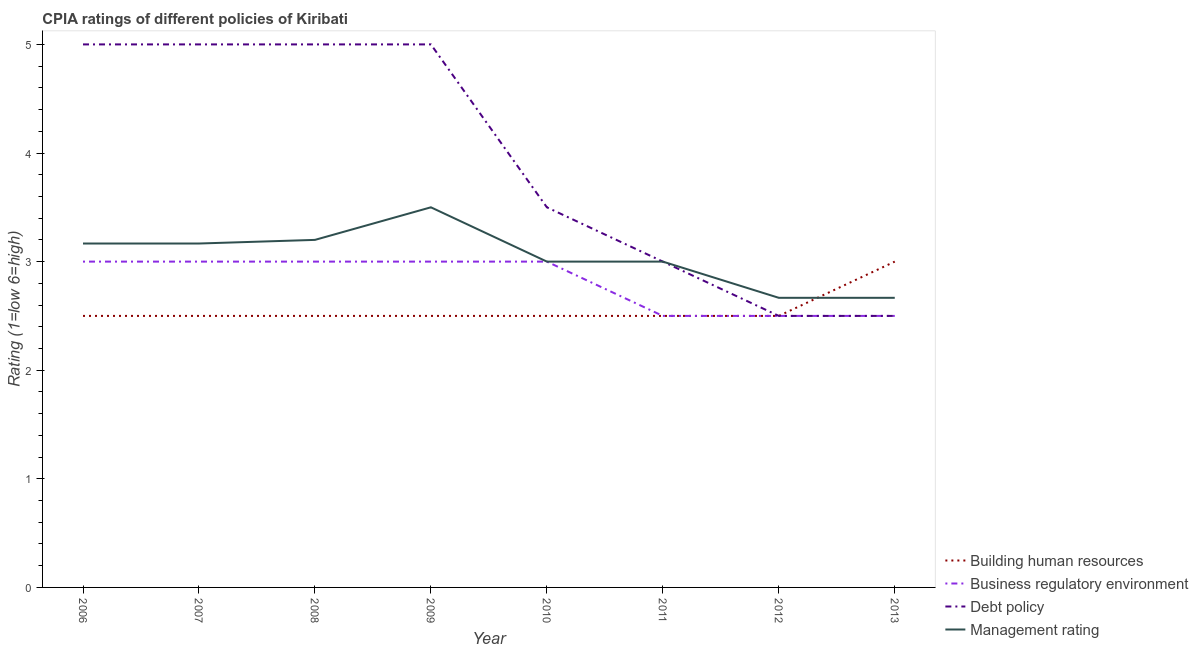How many different coloured lines are there?
Offer a terse response. 4. Is the number of lines equal to the number of legend labels?
Ensure brevity in your answer.  Yes. What is the cpia rating of debt policy in 2007?
Your answer should be very brief. 5. Across all years, what is the maximum cpia rating of business regulatory environment?
Your answer should be very brief. 3. Across all years, what is the minimum cpia rating of debt policy?
Keep it short and to the point. 2.5. In which year was the cpia rating of management maximum?
Keep it short and to the point. 2009. In which year was the cpia rating of business regulatory environment minimum?
Your answer should be very brief. 2011. What is the difference between the cpia rating of management in 2012 and the cpia rating of debt policy in 2007?
Make the answer very short. -2.33. What is the average cpia rating of management per year?
Offer a very short reply. 3.05. In the year 2012, what is the difference between the cpia rating of debt policy and cpia rating of management?
Offer a very short reply. -0.17. In how many years, is the cpia rating of management greater than 3.8?
Ensure brevity in your answer.  0. What is the ratio of the cpia rating of business regulatory environment in 2006 to that in 2013?
Your response must be concise. 1.2. Is the cpia rating of debt policy in 2006 less than that in 2007?
Offer a very short reply. No. Is the difference between the cpia rating of debt policy in 2010 and 2011 greater than the difference between the cpia rating of management in 2010 and 2011?
Keep it short and to the point. Yes. What is the difference between the highest and the second highest cpia rating of building human resources?
Your answer should be compact. 0.5. What is the difference between the highest and the lowest cpia rating of building human resources?
Keep it short and to the point. 0.5. In how many years, is the cpia rating of debt policy greater than the average cpia rating of debt policy taken over all years?
Offer a very short reply. 4. Is the sum of the cpia rating of debt policy in 2007 and 2009 greater than the maximum cpia rating of building human resources across all years?
Provide a short and direct response. Yes. Is it the case that in every year, the sum of the cpia rating of business regulatory environment and cpia rating of building human resources is greater than the sum of cpia rating of debt policy and cpia rating of management?
Your answer should be compact. No. Does the cpia rating of management monotonically increase over the years?
Your answer should be compact. No. Is the cpia rating of debt policy strictly less than the cpia rating of business regulatory environment over the years?
Your answer should be compact. No. How many lines are there?
Offer a very short reply. 4. What is the difference between two consecutive major ticks on the Y-axis?
Offer a terse response. 1. Does the graph contain any zero values?
Provide a succinct answer. No. Does the graph contain grids?
Provide a short and direct response. No. How many legend labels are there?
Your answer should be compact. 4. What is the title of the graph?
Keep it short and to the point. CPIA ratings of different policies of Kiribati. Does "Offering training" appear as one of the legend labels in the graph?
Give a very brief answer. No. What is the label or title of the X-axis?
Keep it short and to the point. Year. What is the Rating (1=low 6=high) of Building human resources in 2006?
Offer a very short reply. 2.5. What is the Rating (1=low 6=high) of Management rating in 2006?
Your response must be concise. 3.17. What is the Rating (1=low 6=high) of Building human resources in 2007?
Make the answer very short. 2.5. What is the Rating (1=low 6=high) in Debt policy in 2007?
Provide a succinct answer. 5. What is the Rating (1=low 6=high) in Management rating in 2007?
Provide a succinct answer. 3.17. What is the Rating (1=low 6=high) in Business regulatory environment in 2008?
Keep it short and to the point. 3. What is the Rating (1=low 6=high) of Management rating in 2008?
Ensure brevity in your answer.  3.2. What is the Rating (1=low 6=high) in Business regulatory environment in 2009?
Your answer should be very brief. 3. What is the Rating (1=low 6=high) of Debt policy in 2009?
Your answer should be very brief. 5. What is the Rating (1=low 6=high) of Management rating in 2009?
Provide a succinct answer. 3.5. What is the Rating (1=low 6=high) in Business regulatory environment in 2010?
Ensure brevity in your answer.  3. What is the Rating (1=low 6=high) in Building human resources in 2011?
Make the answer very short. 2.5. What is the Rating (1=low 6=high) of Debt policy in 2011?
Ensure brevity in your answer.  3. What is the Rating (1=low 6=high) in Management rating in 2012?
Ensure brevity in your answer.  2.67. What is the Rating (1=low 6=high) in Business regulatory environment in 2013?
Make the answer very short. 2.5. What is the Rating (1=low 6=high) of Management rating in 2013?
Your answer should be compact. 2.67. Across all years, what is the maximum Rating (1=low 6=high) of Building human resources?
Your answer should be compact. 3. Across all years, what is the maximum Rating (1=low 6=high) of Business regulatory environment?
Make the answer very short. 3. Across all years, what is the maximum Rating (1=low 6=high) of Management rating?
Ensure brevity in your answer.  3.5. Across all years, what is the minimum Rating (1=low 6=high) in Management rating?
Offer a very short reply. 2.67. What is the total Rating (1=low 6=high) of Building human resources in the graph?
Your answer should be very brief. 20.5. What is the total Rating (1=low 6=high) of Debt policy in the graph?
Your answer should be very brief. 31.5. What is the total Rating (1=low 6=high) of Management rating in the graph?
Offer a very short reply. 24.37. What is the difference between the Rating (1=low 6=high) of Debt policy in 2006 and that in 2007?
Give a very brief answer. 0. What is the difference between the Rating (1=low 6=high) in Building human resources in 2006 and that in 2008?
Ensure brevity in your answer.  0. What is the difference between the Rating (1=low 6=high) of Business regulatory environment in 2006 and that in 2008?
Give a very brief answer. 0. What is the difference between the Rating (1=low 6=high) of Management rating in 2006 and that in 2008?
Your answer should be very brief. -0.03. What is the difference between the Rating (1=low 6=high) of Business regulatory environment in 2006 and that in 2009?
Provide a short and direct response. 0. What is the difference between the Rating (1=low 6=high) of Debt policy in 2006 and that in 2009?
Keep it short and to the point. 0. What is the difference between the Rating (1=low 6=high) of Building human resources in 2006 and that in 2010?
Your response must be concise. 0. What is the difference between the Rating (1=low 6=high) in Debt policy in 2006 and that in 2010?
Make the answer very short. 1.5. What is the difference between the Rating (1=low 6=high) of Management rating in 2006 and that in 2010?
Give a very brief answer. 0.17. What is the difference between the Rating (1=low 6=high) of Building human resources in 2006 and that in 2011?
Your answer should be very brief. 0. What is the difference between the Rating (1=low 6=high) of Business regulatory environment in 2006 and that in 2011?
Provide a succinct answer. 0.5. What is the difference between the Rating (1=low 6=high) of Management rating in 2006 and that in 2011?
Provide a succinct answer. 0.17. What is the difference between the Rating (1=low 6=high) in Building human resources in 2006 and that in 2012?
Provide a succinct answer. 0. What is the difference between the Rating (1=low 6=high) in Management rating in 2006 and that in 2012?
Provide a succinct answer. 0.5. What is the difference between the Rating (1=low 6=high) of Business regulatory environment in 2006 and that in 2013?
Your answer should be compact. 0.5. What is the difference between the Rating (1=low 6=high) of Debt policy in 2006 and that in 2013?
Ensure brevity in your answer.  2.5. What is the difference between the Rating (1=low 6=high) in Building human resources in 2007 and that in 2008?
Your answer should be very brief. 0. What is the difference between the Rating (1=low 6=high) in Debt policy in 2007 and that in 2008?
Provide a succinct answer. 0. What is the difference between the Rating (1=low 6=high) in Management rating in 2007 and that in 2008?
Your response must be concise. -0.03. What is the difference between the Rating (1=low 6=high) in Building human resources in 2007 and that in 2010?
Offer a very short reply. 0. What is the difference between the Rating (1=low 6=high) in Business regulatory environment in 2007 and that in 2010?
Offer a very short reply. 0. What is the difference between the Rating (1=low 6=high) of Debt policy in 2007 and that in 2010?
Provide a succinct answer. 1.5. What is the difference between the Rating (1=low 6=high) of Management rating in 2007 and that in 2010?
Give a very brief answer. 0.17. What is the difference between the Rating (1=low 6=high) in Business regulatory environment in 2007 and that in 2011?
Ensure brevity in your answer.  0.5. What is the difference between the Rating (1=low 6=high) of Business regulatory environment in 2007 and that in 2012?
Offer a terse response. 0.5. What is the difference between the Rating (1=low 6=high) of Debt policy in 2007 and that in 2012?
Your answer should be very brief. 2.5. What is the difference between the Rating (1=low 6=high) in Business regulatory environment in 2008 and that in 2009?
Provide a short and direct response. 0. What is the difference between the Rating (1=low 6=high) in Debt policy in 2008 and that in 2009?
Offer a very short reply. 0. What is the difference between the Rating (1=low 6=high) of Management rating in 2008 and that in 2009?
Make the answer very short. -0.3. What is the difference between the Rating (1=low 6=high) in Debt policy in 2008 and that in 2010?
Keep it short and to the point. 1.5. What is the difference between the Rating (1=low 6=high) in Management rating in 2008 and that in 2010?
Provide a succinct answer. 0.2. What is the difference between the Rating (1=low 6=high) in Debt policy in 2008 and that in 2011?
Your answer should be very brief. 2. What is the difference between the Rating (1=low 6=high) of Business regulatory environment in 2008 and that in 2012?
Make the answer very short. 0.5. What is the difference between the Rating (1=low 6=high) of Debt policy in 2008 and that in 2012?
Ensure brevity in your answer.  2.5. What is the difference between the Rating (1=low 6=high) in Management rating in 2008 and that in 2012?
Make the answer very short. 0.53. What is the difference between the Rating (1=low 6=high) of Building human resources in 2008 and that in 2013?
Your answer should be very brief. -0.5. What is the difference between the Rating (1=low 6=high) in Management rating in 2008 and that in 2013?
Your response must be concise. 0.53. What is the difference between the Rating (1=low 6=high) of Debt policy in 2009 and that in 2010?
Your answer should be compact. 1.5. What is the difference between the Rating (1=low 6=high) of Building human resources in 2009 and that in 2011?
Offer a very short reply. 0. What is the difference between the Rating (1=low 6=high) of Business regulatory environment in 2009 and that in 2011?
Offer a terse response. 0.5. What is the difference between the Rating (1=low 6=high) of Management rating in 2009 and that in 2011?
Make the answer very short. 0.5. What is the difference between the Rating (1=low 6=high) of Business regulatory environment in 2009 and that in 2012?
Your response must be concise. 0.5. What is the difference between the Rating (1=low 6=high) in Management rating in 2009 and that in 2012?
Provide a succinct answer. 0.83. What is the difference between the Rating (1=low 6=high) in Building human resources in 2009 and that in 2013?
Provide a succinct answer. -0.5. What is the difference between the Rating (1=low 6=high) of Business regulatory environment in 2010 and that in 2012?
Make the answer very short. 0.5. What is the difference between the Rating (1=low 6=high) in Management rating in 2010 and that in 2012?
Keep it short and to the point. 0.33. What is the difference between the Rating (1=low 6=high) of Building human resources in 2010 and that in 2013?
Offer a very short reply. -0.5. What is the difference between the Rating (1=low 6=high) of Business regulatory environment in 2010 and that in 2013?
Offer a very short reply. 0.5. What is the difference between the Rating (1=low 6=high) of Debt policy in 2010 and that in 2013?
Your answer should be very brief. 1. What is the difference between the Rating (1=low 6=high) in Management rating in 2010 and that in 2013?
Offer a terse response. 0.33. What is the difference between the Rating (1=low 6=high) in Building human resources in 2011 and that in 2012?
Provide a short and direct response. 0. What is the difference between the Rating (1=low 6=high) of Business regulatory environment in 2011 and that in 2012?
Offer a terse response. 0. What is the difference between the Rating (1=low 6=high) in Management rating in 2011 and that in 2012?
Offer a very short reply. 0.33. What is the difference between the Rating (1=low 6=high) of Management rating in 2011 and that in 2013?
Provide a succinct answer. 0.33. What is the difference between the Rating (1=low 6=high) in Debt policy in 2012 and that in 2013?
Give a very brief answer. 0. What is the difference between the Rating (1=low 6=high) of Management rating in 2012 and that in 2013?
Your response must be concise. 0. What is the difference between the Rating (1=low 6=high) in Business regulatory environment in 2006 and the Rating (1=low 6=high) in Management rating in 2007?
Give a very brief answer. -0.17. What is the difference between the Rating (1=low 6=high) in Debt policy in 2006 and the Rating (1=low 6=high) in Management rating in 2007?
Give a very brief answer. 1.83. What is the difference between the Rating (1=low 6=high) in Building human resources in 2006 and the Rating (1=low 6=high) in Business regulatory environment in 2008?
Offer a very short reply. -0.5. What is the difference between the Rating (1=low 6=high) in Building human resources in 2006 and the Rating (1=low 6=high) in Debt policy in 2008?
Provide a short and direct response. -2.5. What is the difference between the Rating (1=low 6=high) in Building human resources in 2006 and the Rating (1=low 6=high) in Business regulatory environment in 2009?
Your answer should be compact. -0.5. What is the difference between the Rating (1=low 6=high) in Building human resources in 2006 and the Rating (1=low 6=high) in Business regulatory environment in 2010?
Your response must be concise. -0.5. What is the difference between the Rating (1=low 6=high) in Business regulatory environment in 2006 and the Rating (1=low 6=high) in Debt policy in 2010?
Ensure brevity in your answer.  -0.5. What is the difference between the Rating (1=low 6=high) of Business regulatory environment in 2006 and the Rating (1=low 6=high) of Management rating in 2010?
Offer a very short reply. 0. What is the difference between the Rating (1=low 6=high) of Debt policy in 2006 and the Rating (1=low 6=high) of Management rating in 2010?
Your response must be concise. 2. What is the difference between the Rating (1=low 6=high) in Building human resources in 2006 and the Rating (1=low 6=high) in Debt policy in 2011?
Keep it short and to the point. -0.5. What is the difference between the Rating (1=low 6=high) in Building human resources in 2006 and the Rating (1=low 6=high) in Management rating in 2011?
Keep it short and to the point. -0.5. What is the difference between the Rating (1=low 6=high) of Business regulatory environment in 2006 and the Rating (1=low 6=high) of Management rating in 2011?
Your answer should be very brief. 0. What is the difference between the Rating (1=low 6=high) of Debt policy in 2006 and the Rating (1=low 6=high) of Management rating in 2011?
Offer a very short reply. 2. What is the difference between the Rating (1=low 6=high) of Building human resources in 2006 and the Rating (1=low 6=high) of Management rating in 2012?
Offer a terse response. -0.17. What is the difference between the Rating (1=low 6=high) of Business regulatory environment in 2006 and the Rating (1=low 6=high) of Management rating in 2012?
Your answer should be very brief. 0.33. What is the difference between the Rating (1=low 6=high) of Debt policy in 2006 and the Rating (1=low 6=high) of Management rating in 2012?
Make the answer very short. 2.33. What is the difference between the Rating (1=low 6=high) in Building human resources in 2006 and the Rating (1=low 6=high) in Debt policy in 2013?
Your answer should be very brief. 0. What is the difference between the Rating (1=low 6=high) in Business regulatory environment in 2006 and the Rating (1=low 6=high) in Debt policy in 2013?
Make the answer very short. 0.5. What is the difference between the Rating (1=low 6=high) of Business regulatory environment in 2006 and the Rating (1=low 6=high) of Management rating in 2013?
Your answer should be compact. 0.33. What is the difference between the Rating (1=low 6=high) of Debt policy in 2006 and the Rating (1=low 6=high) of Management rating in 2013?
Offer a terse response. 2.33. What is the difference between the Rating (1=low 6=high) in Building human resources in 2007 and the Rating (1=low 6=high) in Business regulatory environment in 2009?
Your answer should be compact. -0.5. What is the difference between the Rating (1=low 6=high) of Building human resources in 2007 and the Rating (1=low 6=high) of Debt policy in 2009?
Ensure brevity in your answer.  -2.5. What is the difference between the Rating (1=low 6=high) of Business regulatory environment in 2007 and the Rating (1=low 6=high) of Debt policy in 2009?
Give a very brief answer. -2. What is the difference between the Rating (1=low 6=high) of Debt policy in 2007 and the Rating (1=low 6=high) of Management rating in 2009?
Give a very brief answer. 1.5. What is the difference between the Rating (1=low 6=high) in Building human resources in 2007 and the Rating (1=low 6=high) in Business regulatory environment in 2010?
Make the answer very short. -0.5. What is the difference between the Rating (1=low 6=high) of Building human resources in 2007 and the Rating (1=low 6=high) of Debt policy in 2010?
Offer a very short reply. -1. What is the difference between the Rating (1=low 6=high) in Building human resources in 2007 and the Rating (1=low 6=high) in Management rating in 2010?
Give a very brief answer. -0.5. What is the difference between the Rating (1=low 6=high) of Business regulatory environment in 2007 and the Rating (1=low 6=high) of Management rating in 2010?
Keep it short and to the point. 0. What is the difference between the Rating (1=low 6=high) of Building human resources in 2007 and the Rating (1=low 6=high) of Business regulatory environment in 2011?
Your response must be concise. 0. What is the difference between the Rating (1=low 6=high) of Business regulatory environment in 2007 and the Rating (1=low 6=high) of Debt policy in 2011?
Give a very brief answer. 0. What is the difference between the Rating (1=low 6=high) of Business regulatory environment in 2007 and the Rating (1=low 6=high) of Management rating in 2011?
Your answer should be compact. 0. What is the difference between the Rating (1=low 6=high) of Debt policy in 2007 and the Rating (1=low 6=high) of Management rating in 2011?
Give a very brief answer. 2. What is the difference between the Rating (1=low 6=high) in Building human resources in 2007 and the Rating (1=low 6=high) in Debt policy in 2012?
Offer a terse response. 0. What is the difference between the Rating (1=low 6=high) of Building human resources in 2007 and the Rating (1=low 6=high) of Management rating in 2012?
Provide a short and direct response. -0.17. What is the difference between the Rating (1=low 6=high) of Business regulatory environment in 2007 and the Rating (1=low 6=high) of Debt policy in 2012?
Your answer should be very brief. 0.5. What is the difference between the Rating (1=low 6=high) of Business regulatory environment in 2007 and the Rating (1=low 6=high) of Management rating in 2012?
Provide a succinct answer. 0.33. What is the difference between the Rating (1=low 6=high) of Debt policy in 2007 and the Rating (1=low 6=high) of Management rating in 2012?
Keep it short and to the point. 2.33. What is the difference between the Rating (1=low 6=high) in Building human resources in 2007 and the Rating (1=low 6=high) in Debt policy in 2013?
Your response must be concise. 0. What is the difference between the Rating (1=low 6=high) of Business regulatory environment in 2007 and the Rating (1=low 6=high) of Debt policy in 2013?
Give a very brief answer. 0.5. What is the difference between the Rating (1=low 6=high) in Business regulatory environment in 2007 and the Rating (1=low 6=high) in Management rating in 2013?
Offer a terse response. 0.33. What is the difference between the Rating (1=low 6=high) of Debt policy in 2007 and the Rating (1=low 6=high) of Management rating in 2013?
Your answer should be very brief. 2.33. What is the difference between the Rating (1=low 6=high) in Building human resources in 2008 and the Rating (1=low 6=high) in Debt policy in 2009?
Your answer should be very brief. -2.5. What is the difference between the Rating (1=low 6=high) in Building human resources in 2008 and the Rating (1=low 6=high) in Management rating in 2009?
Provide a succinct answer. -1. What is the difference between the Rating (1=low 6=high) of Debt policy in 2008 and the Rating (1=low 6=high) of Management rating in 2009?
Offer a very short reply. 1.5. What is the difference between the Rating (1=low 6=high) in Building human resources in 2008 and the Rating (1=low 6=high) in Management rating in 2010?
Provide a succinct answer. -0.5. What is the difference between the Rating (1=low 6=high) of Business regulatory environment in 2008 and the Rating (1=low 6=high) of Management rating in 2010?
Your answer should be compact. 0. What is the difference between the Rating (1=low 6=high) of Debt policy in 2008 and the Rating (1=low 6=high) of Management rating in 2010?
Ensure brevity in your answer.  2. What is the difference between the Rating (1=low 6=high) in Building human resources in 2008 and the Rating (1=low 6=high) in Business regulatory environment in 2011?
Your response must be concise. 0. What is the difference between the Rating (1=low 6=high) of Building human resources in 2008 and the Rating (1=low 6=high) of Management rating in 2011?
Offer a terse response. -0.5. What is the difference between the Rating (1=low 6=high) in Business regulatory environment in 2008 and the Rating (1=low 6=high) in Debt policy in 2011?
Offer a terse response. 0. What is the difference between the Rating (1=low 6=high) of Business regulatory environment in 2008 and the Rating (1=low 6=high) of Management rating in 2011?
Your answer should be compact. 0. What is the difference between the Rating (1=low 6=high) of Business regulatory environment in 2008 and the Rating (1=low 6=high) of Management rating in 2012?
Your answer should be very brief. 0.33. What is the difference between the Rating (1=low 6=high) of Debt policy in 2008 and the Rating (1=low 6=high) of Management rating in 2012?
Offer a terse response. 2.33. What is the difference between the Rating (1=low 6=high) of Building human resources in 2008 and the Rating (1=low 6=high) of Management rating in 2013?
Give a very brief answer. -0.17. What is the difference between the Rating (1=low 6=high) of Business regulatory environment in 2008 and the Rating (1=low 6=high) of Management rating in 2013?
Keep it short and to the point. 0.33. What is the difference between the Rating (1=low 6=high) of Debt policy in 2008 and the Rating (1=low 6=high) of Management rating in 2013?
Your answer should be very brief. 2.33. What is the difference between the Rating (1=low 6=high) of Building human resources in 2009 and the Rating (1=low 6=high) of Management rating in 2010?
Make the answer very short. -0.5. What is the difference between the Rating (1=low 6=high) of Debt policy in 2009 and the Rating (1=low 6=high) of Management rating in 2010?
Offer a terse response. 2. What is the difference between the Rating (1=low 6=high) of Building human resources in 2009 and the Rating (1=low 6=high) of Debt policy in 2011?
Provide a short and direct response. -0.5. What is the difference between the Rating (1=low 6=high) in Business regulatory environment in 2009 and the Rating (1=low 6=high) in Debt policy in 2011?
Offer a terse response. 0. What is the difference between the Rating (1=low 6=high) in Business regulatory environment in 2009 and the Rating (1=low 6=high) in Management rating in 2011?
Provide a short and direct response. 0. What is the difference between the Rating (1=low 6=high) of Building human resources in 2009 and the Rating (1=low 6=high) of Debt policy in 2012?
Provide a short and direct response. 0. What is the difference between the Rating (1=low 6=high) in Business regulatory environment in 2009 and the Rating (1=low 6=high) in Debt policy in 2012?
Provide a succinct answer. 0.5. What is the difference between the Rating (1=low 6=high) in Business regulatory environment in 2009 and the Rating (1=low 6=high) in Management rating in 2012?
Offer a terse response. 0.33. What is the difference between the Rating (1=low 6=high) of Debt policy in 2009 and the Rating (1=low 6=high) of Management rating in 2012?
Your answer should be compact. 2.33. What is the difference between the Rating (1=low 6=high) in Building human resources in 2009 and the Rating (1=low 6=high) in Debt policy in 2013?
Make the answer very short. 0. What is the difference between the Rating (1=low 6=high) in Business regulatory environment in 2009 and the Rating (1=low 6=high) in Debt policy in 2013?
Provide a short and direct response. 0.5. What is the difference between the Rating (1=low 6=high) in Debt policy in 2009 and the Rating (1=low 6=high) in Management rating in 2013?
Your answer should be very brief. 2.33. What is the difference between the Rating (1=low 6=high) of Building human resources in 2010 and the Rating (1=low 6=high) of Business regulatory environment in 2011?
Your answer should be very brief. 0. What is the difference between the Rating (1=low 6=high) of Business regulatory environment in 2010 and the Rating (1=low 6=high) of Debt policy in 2011?
Ensure brevity in your answer.  0. What is the difference between the Rating (1=low 6=high) of Business regulatory environment in 2010 and the Rating (1=low 6=high) of Management rating in 2011?
Make the answer very short. 0. What is the difference between the Rating (1=low 6=high) in Building human resources in 2010 and the Rating (1=low 6=high) in Debt policy in 2012?
Offer a terse response. 0. What is the difference between the Rating (1=low 6=high) of Building human resources in 2010 and the Rating (1=low 6=high) of Management rating in 2012?
Ensure brevity in your answer.  -0.17. What is the difference between the Rating (1=low 6=high) in Business regulatory environment in 2010 and the Rating (1=low 6=high) in Debt policy in 2012?
Give a very brief answer. 0.5. What is the difference between the Rating (1=low 6=high) of Debt policy in 2010 and the Rating (1=low 6=high) of Management rating in 2012?
Your answer should be compact. 0.83. What is the difference between the Rating (1=low 6=high) in Building human resources in 2010 and the Rating (1=low 6=high) in Business regulatory environment in 2013?
Your response must be concise. 0. What is the difference between the Rating (1=low 6=high) in Building human resources in 2010 and the Rating (1=low 6=high) in Debt policy in 2013?
Keep it short and to the point. 0. What is the difference between the Rating (1=low 6=high) in Building human resources in 2010 and the Rating (1=low 6=high) in Management rating in 2013?
Give a very brief answer. -0.17. What is the difference between the Rating (1=low 6=high) of Debt policy in 2010 and the Rating (1=low 6=high) of Management rating in 2013?
Provide a short and direct response. 0.83. What is the difference between the Rating (1=low 6=high) of Building human resources in 2011 and the Rating (1=low 6=high) of Business regulatory environment in 2012?
Give a very brief answer. 0. What is the difference between the Rating (1=low 6=high) of Building human resources in 2011 and the Rating (1=low 6=high) of Management rating in 2012?
Offer a very short reply. -0.17. What is the difference between the Rating (1=low 6=high) of Business regulatory environment in 2011 and the Rating (1=low 6=high) of Debt policy in 2012?
Your response must be concise. 0. What is the difference between the Rating (1=low 6=high) in Building human resources in 2012 and the Rating (1=low 6=high) in Business regulatory environment in 2013?
Make the answer very short. 0. What is the difference between the Rating (1=low 6=high) in Building human resources in 2012 and the Rating (1=low 6=high) in Debt policy in 2013?
Ensure brevity in your answer.  0. What is the difference between the Rating (1=low 6=high) of Business regulatory environment in 2012 and the Rating (1=low 6=high) of Debt policy in 2013?
Keep it short and to the point. 0. What is the difference between the Rating (1=low 6=high) of Business regulatory environment in 2012 and the Rating (1=low 6=high) of Management rating in 2013?
Your response must be concise. -0.17. What is the average Rating (1=low 6=high) in Building human resources per year?
Your response must be concise. 2.56. What is the average Rating (1=low 6=high) in Business regulatory environment per year?
Your answer should be very brief. 2.81. What is the average Rating (1=low 6=high) in Debt policy per year?
Your answer should be compact. 3.94. What is the average Rating (1=low 6=high) in Management rating per year?
Provide a succinct answer. 3.05. In the year 2006, what is the difference between the Rating (1=low 6=high) of Building human resources and Rating (1=low 6=high) of Business regulatory environment?
Provide a succinct answer. -0.5. In the year 2006, what is the difference between the Rating (1=low 6=high) of Business regulatory environment and Rating (1=low 6=high) of Management rating?
Offer a very short reply. -0.17. In the year 2006, what is the difference between the Rating (1=low 6=high) in Debt policy and Rating (1=low 6=high) in Management rating?
Ensure brevity in your answer.  1.83. In the year 2007, what is the difference between the Rating (1=low 6=high) of Building human resources and Rating (1=low 6=high) of Debt policy?
Keep it short and to the point. -2.5. In the year 2007, what is the difference between the Rating (1=low 6=high) in Building human resources and Rating (1=low 6=high) in Management rating?
Your answer should be compact. -0.67. In the year 2007, what is the difference between the Rating (1=low 6=high) in Business regulatory environment and Rating (1=low 6=high) in Debt policy?
Your answer should be very brief. -2. In the year 2007, what is the difference between the Rating (1=low 6=high) of Business regulatory environment and Rating (1=low 6=high) of Management rating?
Provide a short and direct response. -0.17. In the year 2007, what is the difference between the Rating (1=low 6=high) of Debt policy and Rating (1=low 6=high) of Management rating?
Your answer should be very brief. 1.83. In the year 2008, what is the difference between the Rating (1=low 6=high) of Building human resources and Rating (1=low 6=high) of Management rating?
Keep it short and to the point. -0.7. In the year 2008, what is the difference between the Rating (1=low 6=high) in Debt policy and Rating (1=low 6=high) in Management rating?
Your answer should be compact. 1.8. In the year 2010, what is the difference between the Rating (1=low 6=high) in Building human resources and Rating (1=low 6=high) in Debt policy?
Your answer should be very brief. -1. In the year 2010, what is the difference between the Rating (1=low 6=high) in Building human resources and Rating (1=low 6=high) in Management rating?
Keep it short and to the point. -0.5. In the year 2010, what is the difference between the Rating (1=low 6=high) of Business regulatory environment and Rating (1=low 6=high) of Debt policy?
Give a very brief answer. -0.5. In the year 2010, what is the difference between the Rating (1=low 6=high) of Debt policy and Rating (1=low 6=high) of Management rating?
Provide a short and direct response. 0.5. In the year 2011, what is the difference between the Rating (1=low 6=high) in Business regulatory environment and Rating (1=low 6=high) in Management rating?
Keep it short and to the point. -0.5. In the year 2011, what is the difference between the Rating (1=low 6=high) in Debt policy and Rating (1=low 6=high) in Management rating?
Ensure brevity in your answer.  0. In the year 2012, what is the difference between the Rating (1=low 6=high) in Building human resources and Rating (1=low 6=high) in Debt policy?
Your response must be concise. 0. In the year 2012, what is the difference between the Rating (1=low 6=high) of Building human resources and Rating (1=low 6=high) of Management rating?
Ensure brevity in your answer.  -0.17. In the year 2012, what is the difference between the Rating (1=low 6=high) of Business regulatory environment and Rating (1=low 6=high) of Debt policy?
Your answer should be compact. 0. In the year 2013, what is the difference between the Rating (1=low 6=high) of Business regulatory environment and Rating (1=low 6=high) of Debt policy?
Your answer should be very brief. 0. In the year 2013, what is the difference between the Rating (1=low 6=high) of Debt policy and Rating (1=low 6=high) of Management rating?
Provide a succinct answer. -0.17. What is the ratio of the Rating (1=low 6=high) in Debt policy in 2006 to that in 2007?
Provide a succinct answer. 1. What is the ratio of the Rating (1=low 6=high) of Management rating in 2006 to that in 2007?
Your answer should be very brief. 1. What is the ratio of the Rating (1=low 6=high) of Business regulatory environment in 2006 to that in 2008?
Ensure brevity in your answer.  1. What is the ratio of the Rating (1=low 6=high) in Management rating in 2006 to that in 2008?
Make the answer very short. 0.99. What is the ratio of the Rating (1=low 6=high) of Business regulatory environment in 2006 to that in 2009?
Offer a very short reply. 1. What is the ratio of the Rating (1=low 6=high) of Management rating in 2006 to that in 2009?
Give a very brief answer. 0.9. What is the ratio of the Rating (1=low 6=high) of Business regulatory environment in 2006 to that in 2010?
Your answer should be very brief. 1. What is the ratio of the Rating (1=low 6=high) in Debt policy in 2006 to that in 2010?
Keep it short and to the point. 1.43. What is the ratio of the Rating (1=low 6=high) in Management rating in 2006 to that in 2010?
Give a very brief answer. 1.06. What is the ratio of the Rating (1=low 6=high) of Management rating in 2006 to that in 2011?
Ensure brevity in your answer.  1.06. What is the ratio of the Rating (1=low 6=high) of Building human resources in 2006 to that in 2012?
Keep it short and to the point. 1. What is the ratio of the Rating (1=low 6=high) in Debt policy in 2006 to that in 2012?
Your response must be concise. 2. What is the ratio of the Rating (1=low 6=high) in Management rating in 2006 to that in 2012?
Your answer should be compact. 1.19. What is the ratio of the Rating (1=low 6=high) of Business regulatory environment in 2006 to that in 2013?
Offer a very short reply. 1.2. What is the ratio of the Rating (1=low 6=high) in Debt policy in 2006 to that in 2013?
Keep it short and to the point. 2. What is the ratio of the Rating (1=low 6=high) in Management rating in 2006 to that in 2013?
Make the answer very short. 1.19. What is the ratio of the Rating (1=low 6=high) of Building human resources in 2007 to that in 2008?
Your response must be concise. 1. What is the ratio of the Rating (1=low 6=high) in Debt policy in 2007 to that in 2008?
Make the answer very short. 1. What is the ratio of the Rating (1=low 6=high) in Management rating in 2007 to that in 2008?
Make the answer very short. 0.99. What is the ratio of the Rating (1=low 6=high) of Building human resources in 2007 to that in 2009?
Offer a very short reply. 1. What is the ratio of the Rating (1=low 6=high) in Business regulatory environment in 2007 to that in 2009?
Your response must be concise. 1. What is the ratio of the Rating (1=low 6=high) in Management rating in 2007 to that in 2009?
Ensure brevity in your answer.  0.9. What is the ratio of the Rating (1=low 6=high) in Building human resources in 2007 to that in 2010?
Your answer should be compact. 1. What is the ratio of the Rating (1=low 6=high) of Business regulatory environment in 2007 to that in 2010?
Make the answer very short. 1. What is the ratio of the Rating (1=low 6=high) of Debt policy in 2007 to that in 2010?
Provide a succinct answer. 1.43. What is the ratio of the Rating (1=low 6=high) in Management rating in 2007 to that in 2010?
Make the answer very short. 1.06. What is the ratio of the Rating (1=low 6=high) of Building human resources in 2007 to that in 2011?
Your response must be concise. 1. What is the ratio of the Rating (1=low 6=high) of Business regulatory environment in 2007 to that in 2011?
Your answer should be very brief. 1.2. What is the ratio of the Rating (1=low 6=high) in Debt policy in 2007 to that in 2011?
Provide a succinct answer. 1.67. What is the ratio of the Rating (1=low 6=high) of Management rating in 2007 to that in 2011?
Provide a short and direct response. 1.06. What is the ratio of the Rating (1=low 6=high) of Building human resources in 2007 to that in 2012?
Offer a terse response. 1. What is the ratio of the Rating (1=low 6=high) in Debt policy in 2007 to that in 2012?
Offer a terse response. 2. What is the ratio of the Rating (1=low 6=high) of Management rating in 2007 to that in 2012?
Your response must be concise. 1.19. What is the ratio of the Rating (1=low 6=high) of Building human resources in 2007 to that in 2013?
Your response must be concise. 0.83. What is the ratio of the Rating (1=low 6=high) of Debt policy in 2007 to that in 2013?
Offer a terse response. 2. What is the ratio of the Rating (1=low 6=high) of Management rating in 2007 to that in 2013?
Your response must be concise. 1.19. What is the ratio of the Rating (1=low 6=high) of Management rating in 2008 to that in 2009?
Provide a succinct answer. 0.91. What is the ratio of the Rating (1=low 6=high) of Building human resources in 2008 to that in 2010?
Keep it short and to the point. 1. What is the ratio of the Rating (1=low 6=high) of Debt policy in 2008 to that in 2010?
Make the answer very short. 1.43. What is the ratio of the Rating (1=low 6=high) of Management rating in 2008 to that in 2010?
Make the answer very short. 1.07. What is the ratio of the Rating (1=low 6=high) of Management rating in 2008 to that in 2011?
Give a very brief answer. 1.07. What is the ratio of the Rating (1=low 6=high) of Debt policy in 2008 to that in 2012?
Provide a succinct answer. 2. What is the ratio of the Rating (1=low 6=high) in Debt policy in 2008 to that in 2013?
Give a very brief answer. 2. What is the ratio of the Rating (1=low 6=high) of Debt policy in 2009 to that in 2010?
Your response must be concise. 1.43. What is the ratio of the Rating (1=low 6=high) in Management rating in 2009 to that in 2010?
Offer a very short reply. 1.17. What is the ratio of the Rating (1=low 6=high) in Business regulatory environment in 2009 to that in 2011?
Give a very brief answer. 1.2. What is the ratio of the Rating (1=low 6=high) of Building human resources in 2009 to that in 2012?
Your answer should be very brief. 1. What is the ratio of the Rating (1=low 6=high) of Debt policy in 2009 to that in 2012?
Keep it short and to the point. 2. What is the ratio of the Rating (1=low 6=high) of Management rating in 2009 to that in 2012?
Make the answer very short. 1.31. What is the ratio of the Rating (1=low 6=high) in Business regulatory environment in 2009 to that in 2013?
Offer a very short reply. 1.2. What is the ratio of the Rating (1=low 6=high) in Debt policy in 2009 to that in 2013?
Your response must be concise. 2. What is the ratio of the Rating (1=low 6=high) in Management rating in 2009 to that in 2013?
Give a very brief answer. 1.31. What is the ratio of the Rating (1=low 6=high) in Building human resources in 2010 to that in 2011?
Offer a terse response. 1. What is the ratio of the Rating (1=low 6=high) of Business regulatory environment in 2010 to that in 2011?
Provide a succinct answer. 1.2. What is the ratio of the Rating (1=low 6=high) in Management rating in 2010 to that in 2011?
Ensure brevity in your answer.  1. What is the ratio of the Rating (1=low 6=high) in Business regulatory environment in 2010 to that in 2012?
Offer a very short reply. 1.2. What is the ratio of the Rating (1=low 6=high) in Management rating in 2010 to that in 2012?
Provide a short and direct response. 1.12. What is the ratio of the Rating (1=low 6=high) in Business regulatory environment in 2010 to that in 2013?
Make the answer very short. 1.2. What is the ratio of the Rating (1=low 6=high) in Debt policy in 2010 to that in 2013?
Keep it short and to the point. 1.4. What is the ratio of the Rating (1=low 6=high) in Building human resources in 2011 to that in 2013?
Offer a terse response. 0.83. What is the ratio of the Rating (1=low 6=high) of Management rating in 2011 to that in 2013?
Your answer should be very brief. 1.12. What is the ratio of the Rating (1=low 6=high) of Building human resources in 2012 to that in 2013?
Keep it short and to the point. 0.83. What is the difference between the highest and the second highest Rating (1=low 6=high) of Building human resources?
Keep it short and to the point. 0.5. What is the difference between the highest and the second highest Rating (1=low 6=high) in Business regulatory environment?
Give a very brief answer. 0. What is the difference between the highest and the second highest Rating (1=low 6=high) in Management rating?
Offer a terse response. 0.3. What is the difference between the highest and the lowest Rating (1=low 6=high) in Building human resources?
Offer a very short reply. 0.5. What is the difference between the highest and the lowest Rating (1=low 6=high) of Business regulatory environment?
Ensure brevity in your answer.  0.5. 